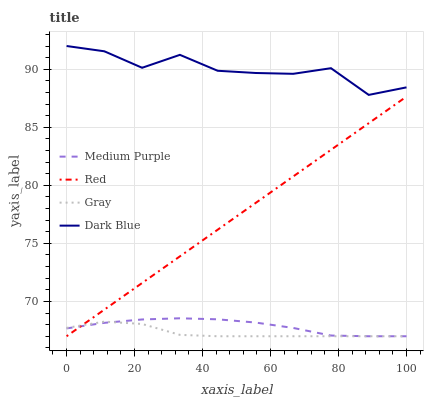Does Red have the minimum area under the curve?
Answer yes or no. No. Does Red have the maximum area under the curve?
Answer yes or no. No. Is Gray the smoothest?
Answer yes or no. No. Is Gray the roughest?
Answer yes or no. No. Does Dark Blue have the lowest value?
Answer yes or no. No. Does Red have the highest value?
Answer yes or no. No. Is Medium Purple less than Dark Blue?
Answer yes or no. Yes. Is Dark Blue greater than Gray?
Answer yes or no. Yes. Does Medium Purple intersect Dark Blue?
Answer yes or no. No. 